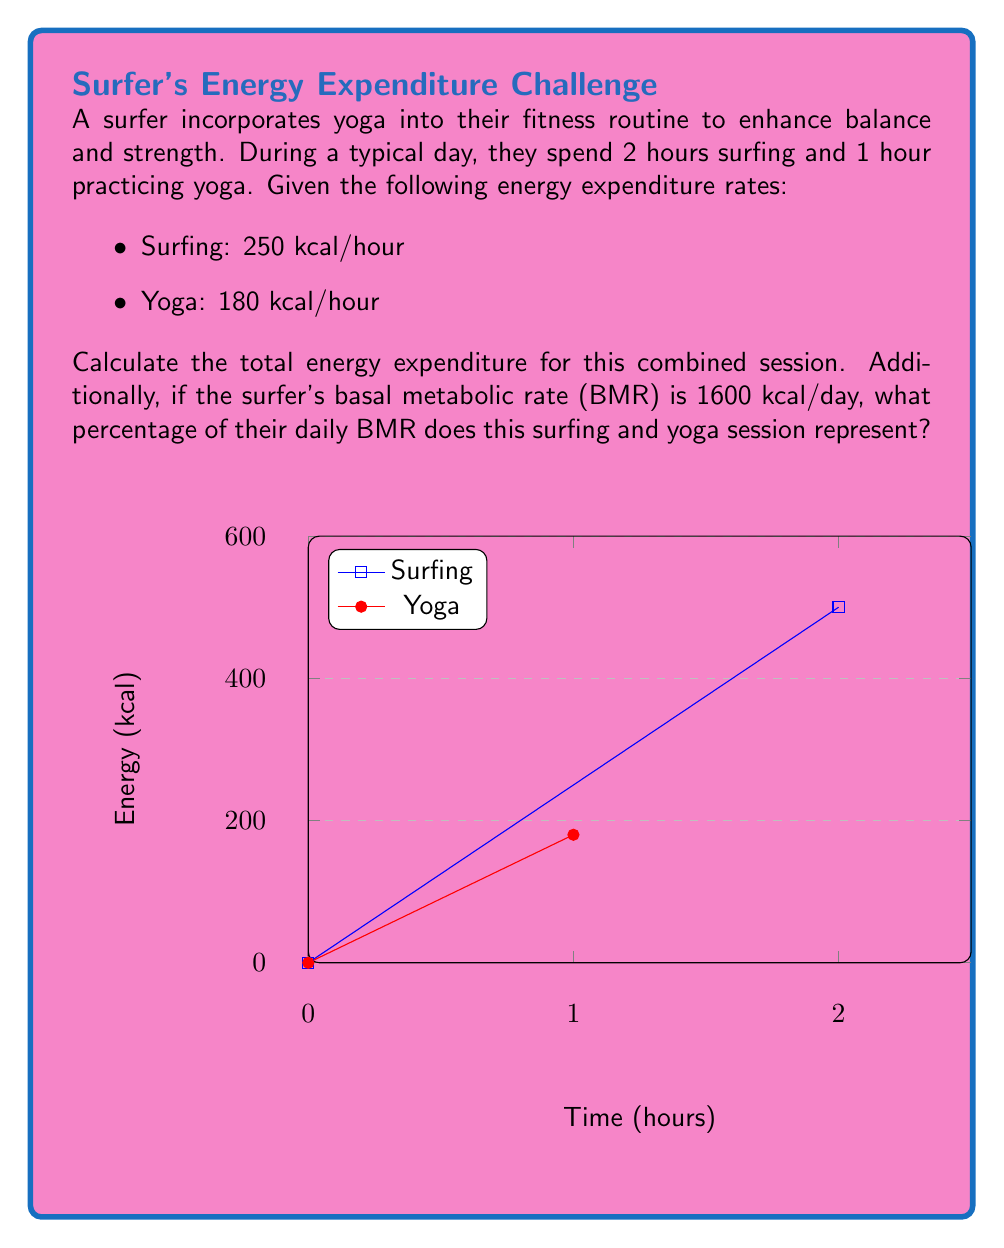Give your solution to this math problem. Let's approach this problem step-by-step:

1) Calculate energy expenditure for surfing:
   $$E_{surf} = 250 \text{ kcal/hour} \times 2 \text{ hours} = 500 \text{ kcal}$$

2) Calculate energy expenditure for yoga:
   $$E_{yoga} = 180 \text{ kcal/hour} \times 1 \text{ hour} = 180 \text{ kcal}$$

3) Calculate total energy expenditure:
   $$E_{total} = E_{surf} + E_{yoga} = 500 \text{ kcal} + 180 \text{ kcal} = 680 \text{ kcal}$$

4) Calculate the percentage of daily BMR:
   $$\text{Percentage of BMR} = \frac{E_{total}}{\text{BMR}} \times 100\%$$
   $$= \frac{680 \text{ kcal}}{1600 \text{ kcal/day}} \times 100\% = 42.5\%$$

Therefore, the total energy expenditure is 680 kcal, which represents 42.5% of the surfer's daily BMR.
Answer: 680 kcal; 42.5% of daily BMR 